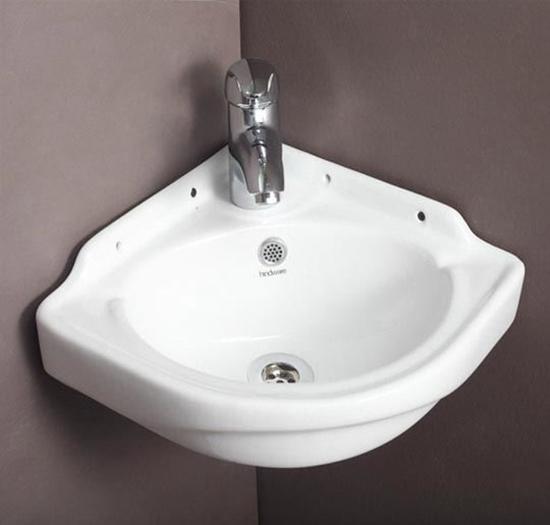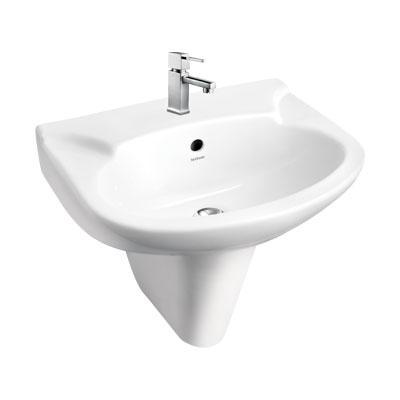The first image is the image on the left, the second image is the image on the right. Evaluate the accuracy of this statement regarding the images: "The image on the right has a plain white background.". Is it true? Answer yes or no. Yes. 